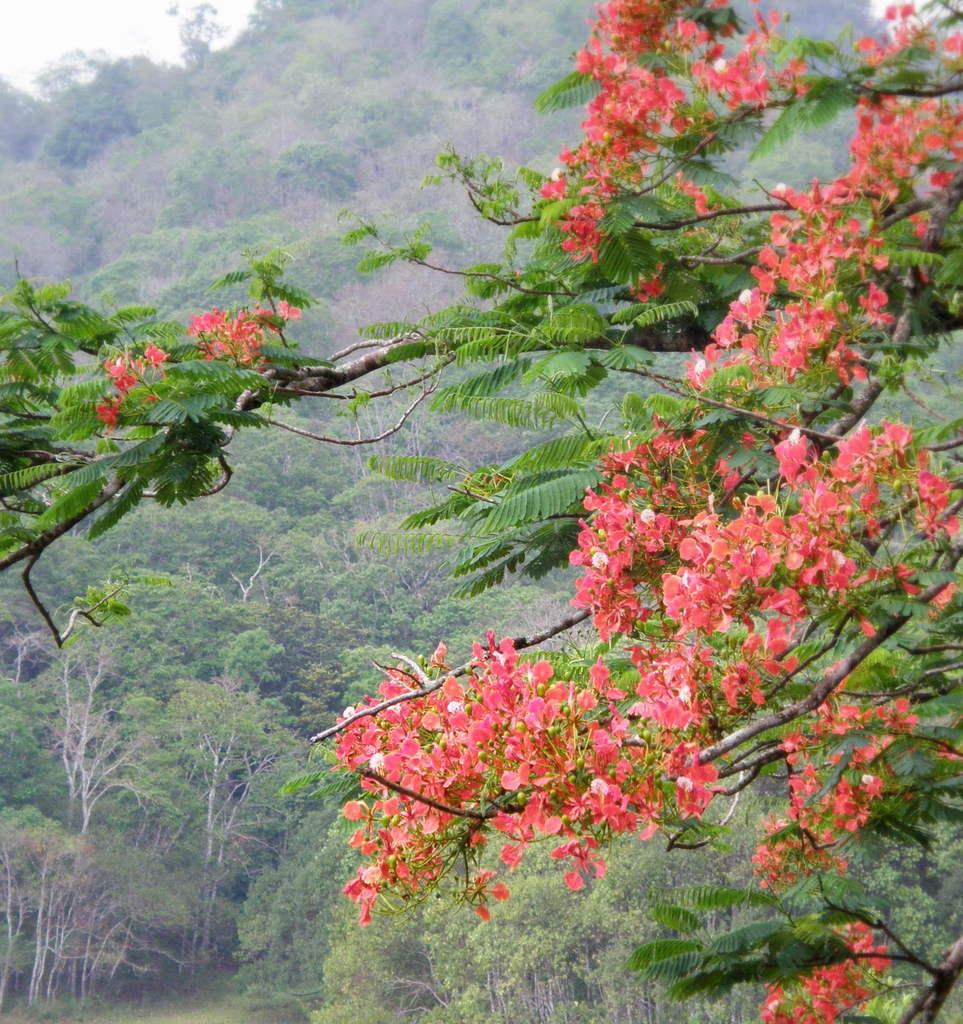What color are the flowers in the image? The flowers in the image are peach-colored. What can be seen in the background of the image? There are trees in green color in the background of the image. What is the color of the sky in the image? The sky appears to be white in color. Is there any thunder or sleet visible in the image? No, there is no thunder or sleet present in the image. The sky appears to be white, but there is no indication of any weather conditions like thunder or sleet. 